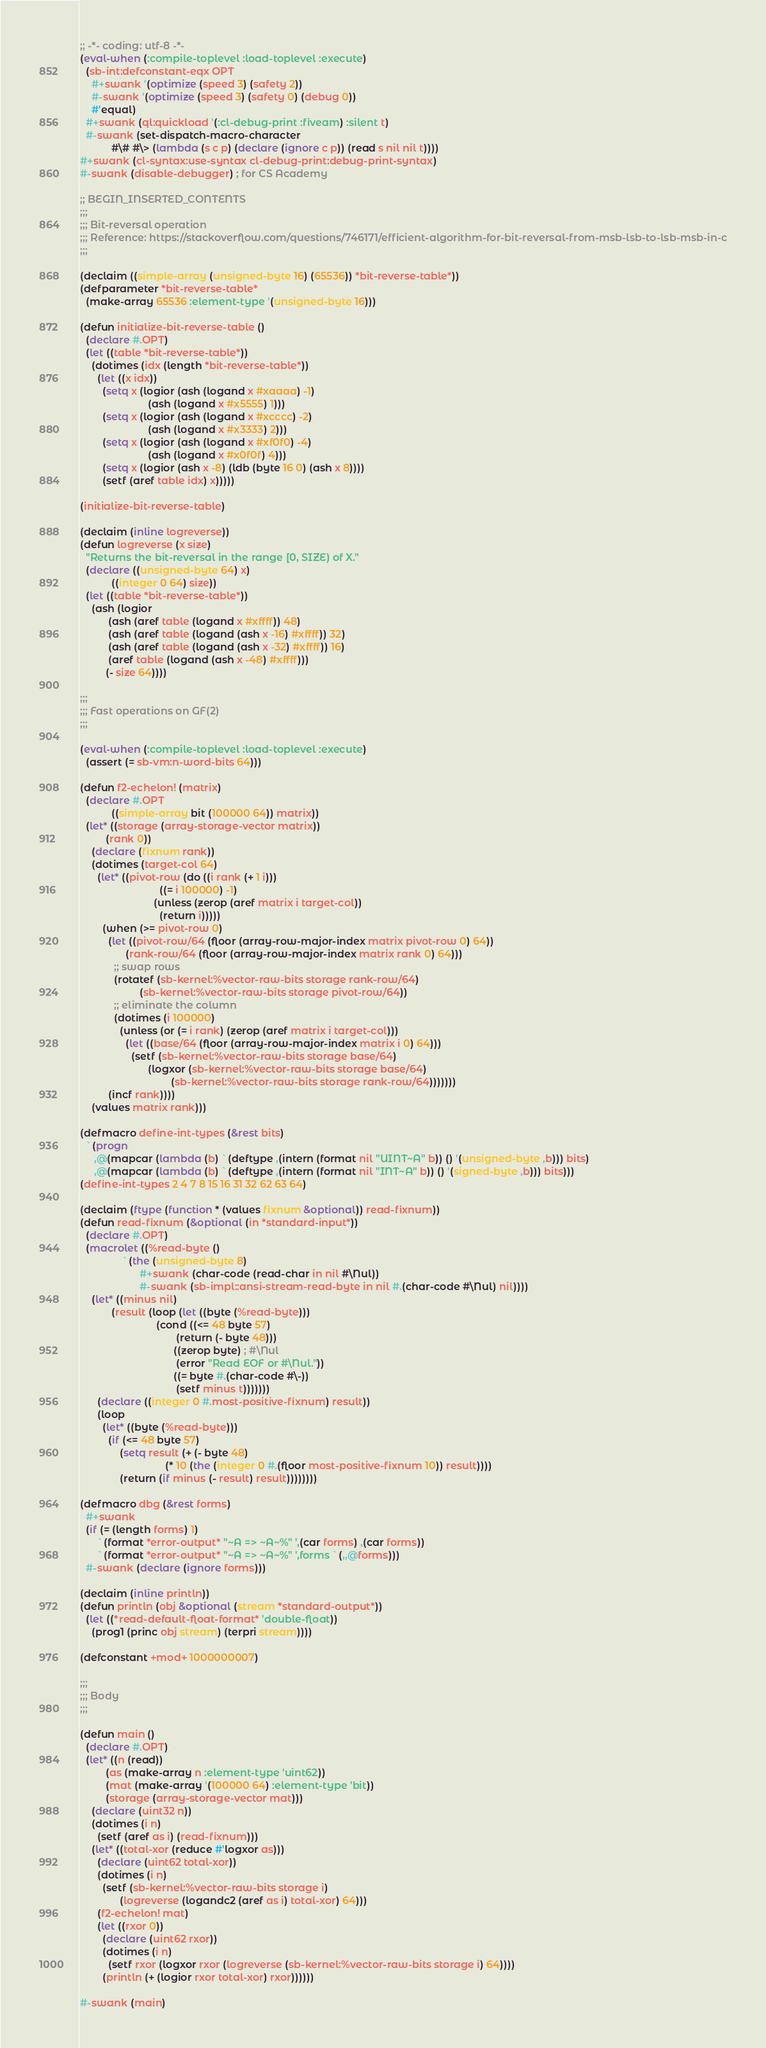Convert code to text. <code><loc_0><loc_0><loc_500><loc_500><_Lisp_>;; -*- coding: utf-8 -*-
(eval-when (:compile-toplevel :load-toplevel :execute)
  (sb-int:defconstant-eqx OPT
    #+swank '(optimize (speed 3) (safety 2))
    #-swank '(optimize (speed 3) (safety 0) (debug 0))
    #'equal)
  #+swank (ql:quickload '(:cl-debug-print :fiveam) :silent t)
  #-swank (set-dispatch-macro-character
           #\# #\> (lambda (s c p) (declare (ignore c p)) (read s nil nil t))))
#+swank (cl-syntax:use-syntax cl-debug-print:debug-print-syntax)
#-swank (disable-debugger) ; for CS Academy

;; BEGIN_INSERTED_CONTENTS
;;;
;;; Bit-reversal operation
;;; Reference: https://stackoverflow.com/questions/746171/efficient-algorithm-for-bit-reversal-from-msb-lsb-to-lsb-msb-in-c
;;;

(declaim ((simple-array (unsigned-byte 16) (65536)) *bit-reverse-table*))
(defparameter *bit-reverse-table*
  (make-array 65536 :element-type '(unsigned-byte 16)))

(defun initialize-bit-reverse-table ()
  (declare #.OPT)
  (let ((table *bit-reverse-table*))
    (dotimes (idx (length *bit-reverse-table*))
      (let ((x idx))
        (setq x (logior (ash (logand x #xaaaa) -1)
                        (ash (logand x #x5555) 1)))
        (setq x (logior (ash (logand x #xcccc) -2)
                        (ash (logand x #x3333) 2)))
        (setq x (logior (ash (logand x #xf0f0) -4)
                        (ash (logand x #x0f0f) 4)))
        (setq x (logior (ash x -8) (ldb (byte 16 0) (ash x 8))))
        (setf (aref table idx) x)))))

(initialize-bit-reverse-table)

(declaim (inline logreverse))
(defun logreverse (x size)
  "Returns the bit-reversal in the range [0, SIZE) of X."
  (declare ((unsigned-byte 64) x)
           ((integer 0 64) size))
  (let ((table *bit-reverse-table*))
    (ash (logior
          (ash (aref table (logand x #xffff)) 48)
          (ash (aref table (logand (ash x -16) #xffff)) 32)
          (ash (aref table (logand (ash x -32) #xffff)) 16)
          (aref table (logand (ash x -48) #xffff)))
         (- size 64))))

;;;
;;; Fast operations on GF(2)
;;;

(eval-when (:compile-toplevel :load-toplevel :execute)
  (assert (= sb-vm:n-word-bits 64)))

(defun f2-echelon! (matrix)
  (declare #.OPT
           ((simple-array bit (100000 64)) matrix))
  (let* ((storage (array-storage-vector matrix))
         (rank 0))
    (declare (fixnum rank))
    (dotimes (target-col 64)
      (let* ((pivot-row (do ((i rank (+ 1 i)))
                            ((= i 100000) -1)
                          (unless (zerop (aref matrix i target-col))
                            (return i)))))
        (when (>= pivot-row 0)
          (let ((pivot-row/64 (floor (array-row-major-index matrix pivot-row 0) 64))
                (rank-row/64 (floor (array-row-major-index matrix rank 0) 64)))
            ;; swap rows
            (rotatef (sb-kernel:%vector-raw-bits storage rank-row/64)
                     (sb-kernel:%vector-raw-bits storage pivot-row/64))
            ;; eliminate the column
            (dotimes (i 100000)
              (unless (or (= i rank) (zerop (aref matrix i target-col)))
                (let ((base/64 (floor (array-row-major-index matrix i 0) 64)))
                  (setf (sb-kernel:%vector-raw-bits storage base/64)
                        (logxor (sb-kernel:%vector-raw-bits storage base/64)
                                (sb-kernel:%vector-raw-bits storage rank-row/64)))))))
          (incf rank))))
    (values matrix rank)))

(defmacro define-int-types (&rest bits)
  `(progn
     ,@(mapcar (lambda (b) `(deftype ,(intern (format nil "UINT~A" b)) () '(unsigned-byte ,b))) bits)
     ,@(mapcar (lambda (b) `(deftype ,(intern (format nil "INT~A" b)) () '(signed-byte ,b))) bits)))
(define-int-types 2 4 7 8 15 16 31 32 62 63 64)

(declaim (ftype (function * (values fixnum &optional)) read-fixnum))
(defun read-fixnum (&optional (in *standard-input*))
  (declare #.OPT)
  (macrolet ((%read-byte ()
               `(the (unsigned-byte 8)
                     #+swank (char-code (read-char in nil #\Nul))
                     #-swank (sb-impl::ansi-stream-read-byte in nil #.(char-code #\Nul) nil))))
    (let* ((minus nil)
           (result (loop (let ((byte (%read-byte)))
                           (cond ((<= 48 byte 57)
                                  (return (- byte 48)))
                                 ((zerop byte) ; #\Nul
                                  (error "Read EOF or #\Nul."))
                                 ((= byte #.(char-code #\-))
                                  (setf minus t)))))))
      (declare ((integer 0 #.most-positive-fixnum) result))
      (loop
        (let* ((byte (%read-byte)))
          (if (<= 48 byte 57)
              (setq result (+ (- byte 48)
                              (* 10 (the (integer 0 #.(floor most-positive-fixnum 10)) result))))
              (return (if minus (- result) result))))))))

(defmacro dbg (&rest forms)
  #+swank
  (if (= (length forms) 1)
      `(format *error-output* "~A => ~A~%" ',(car forms) ,(car forms))
      `(format *error-output* "~A => ~A~%" ',forms `(,,@forms)))
  #-swank (declare (ignore forms)))

(declaim (inline println))
(defun println (obj &optional (stream *standard-output*))
  (let ((*read-default-float-format* 'double-float))
    (prog1 (princ obj stream) (terpri stream))))

(defconstant +mod+ 1000000007)

;;;
;;; Body
;;;

(defun main ()
  (declare #.OPT)
  (let* ((n (read))
         (as (make-array n :element-type 'uint62))
         (mat (make-array '(100000 64) :element-type 'bit))
         (storage (array-storage-vector mat)))
    (declare (uint32 n))
    (dotimes (i n)
      (setf (aref as i) (read-fixnum)))
    (let* ((total-xor (reduce #'logxor as)))
      (declare (uint62 total-xor))
      (dotimes (i n)
        (setf (sb-kernel:%vector-raw-bits storage i)
              (logreverse (logandc2 (aref as i) total-xor) 64)))
      (f2-echelon! mat)
      (let ((rxor 0))
        (declare (uint62 rxor))
        (dotimes (i n)
          (setf rxor (logxor rxor (logreverse (sb-kernel:%vector-raw-bits storage i) 64))))
        (println (+ (logior rxor total-xor) rxor))))))

#-swank (main)
</code> 